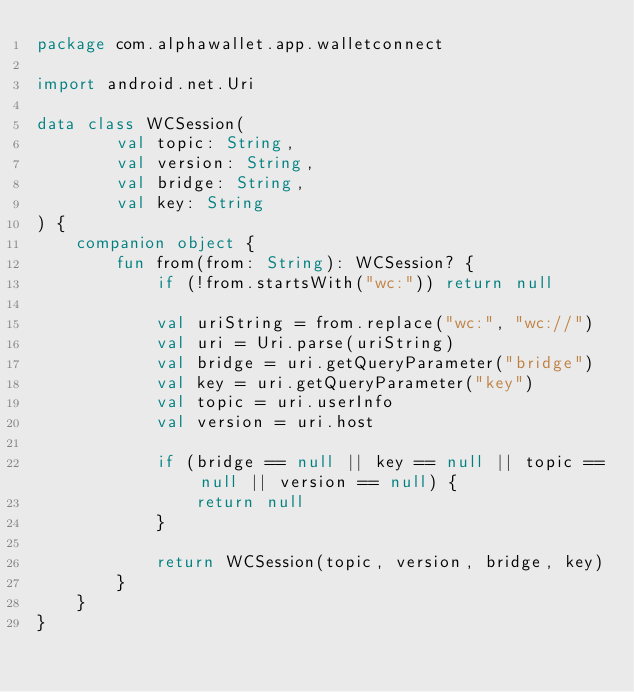<code> <loc_0><loc_0><loc_500><loc_500><_Kotlin_>package com.alphawallet.app.walletconnect

import android.net.Uri

data class WCSession(
        val topic: String,
        val version: String,
        val bridge: String,
        val key: String
) {
    companion object {
        fun from(from: String): WCSession? {
            if (!from.startsWith("wc:")) return null

            val uriString = from.replace("wc:", "wc://")
            val uri = Uri.parse(uriString)
            val bridge = uri.getQueryParameter("bridge")
            val key = uri.getQueryParameter("key")
            val topic = uri.userInfo
            val version = uri.host

            if (bridge == null || key == null || topic == null || version == null) {
                return null
            }

            return WCSession(topic, version, bridge, key)
        }
    }
}</code> 